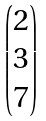<formula> <loc_0><loc_0><loc_500><loc_500>\begin{pmatrix} 2 \\ 3 \\ 7 \end{pmatrix}</formula> 